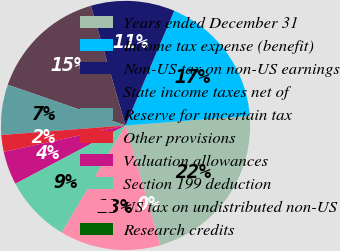Convert chart to OTSL. <chart><loc_0><loc_0><loc_500><loc_500><pie_chart><fcel>Years ended December 31<fcel>Income tax expense (benefit)<fcel>Non-US tax on non-US earnings<fcel>State income taxes net of<fcel>Reserve for uncertain tax<fcel>Other provisions<fcel>Valuation allowances<fcel>Section 199 deduction<fcel>US tax on undistributed non-US<fcel>Research credits<nl><fcel>21.74%<fcel>17.39%<fcel>10.87%<fcel>15.22%<fcel>6.52%<fcel>2.18%<fcel>4.35%<fcel>8.7%<fcel>13.04%<fcel>0.0%<nl></chart> 